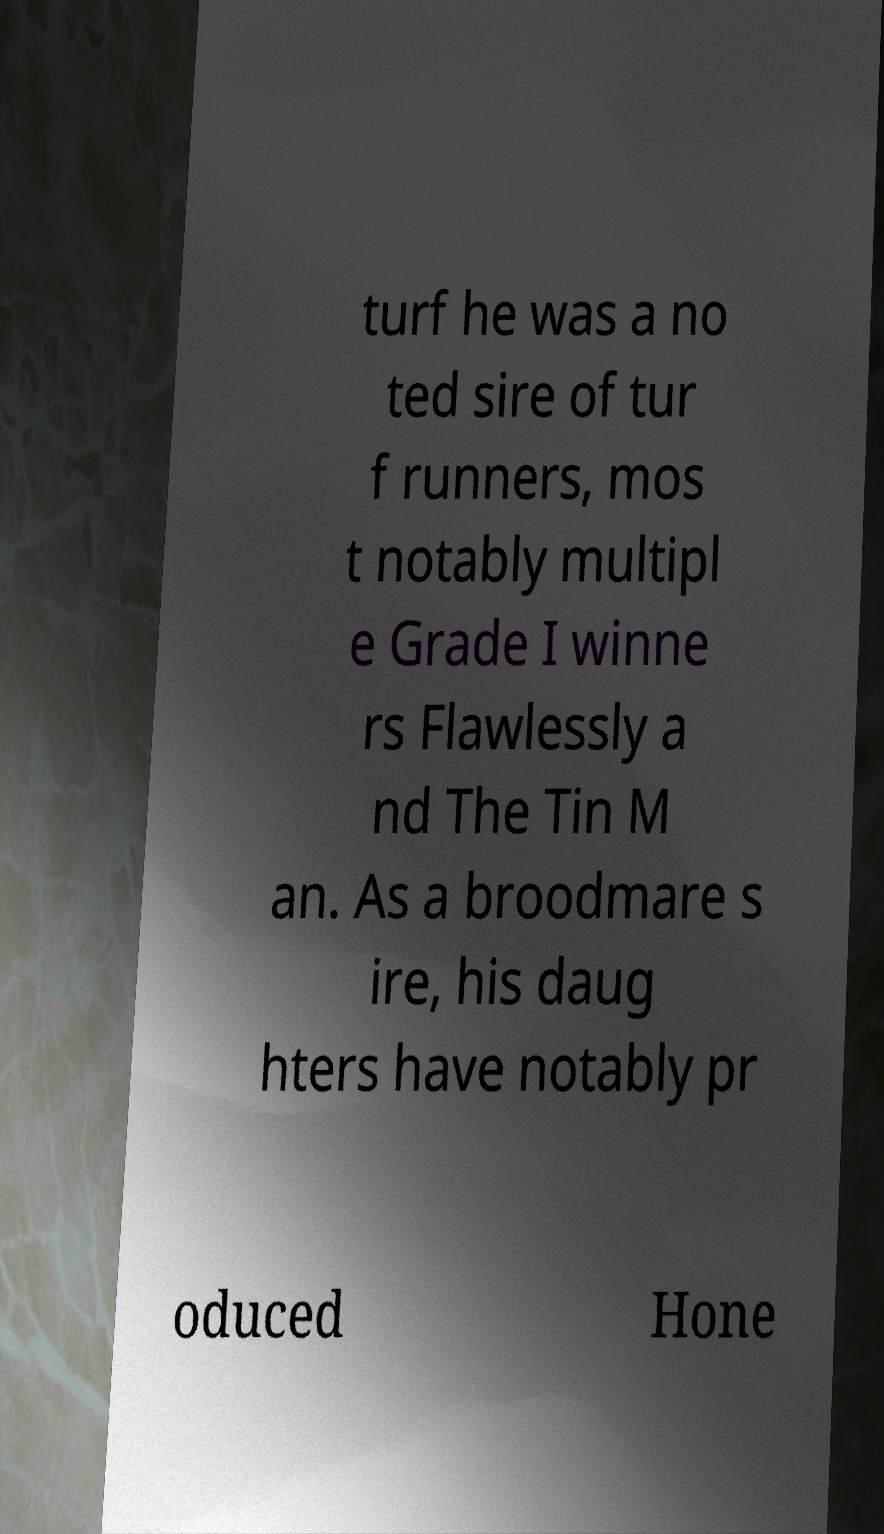Please identify and transcribe the text found in this image. turf he was a no ted sire of tur f runners, mos t notably multipl e Grade I winne rs Flawlessly a nd The Tin M an. As a broodmare s ire, his daug hters have notably pr oduced Hone 